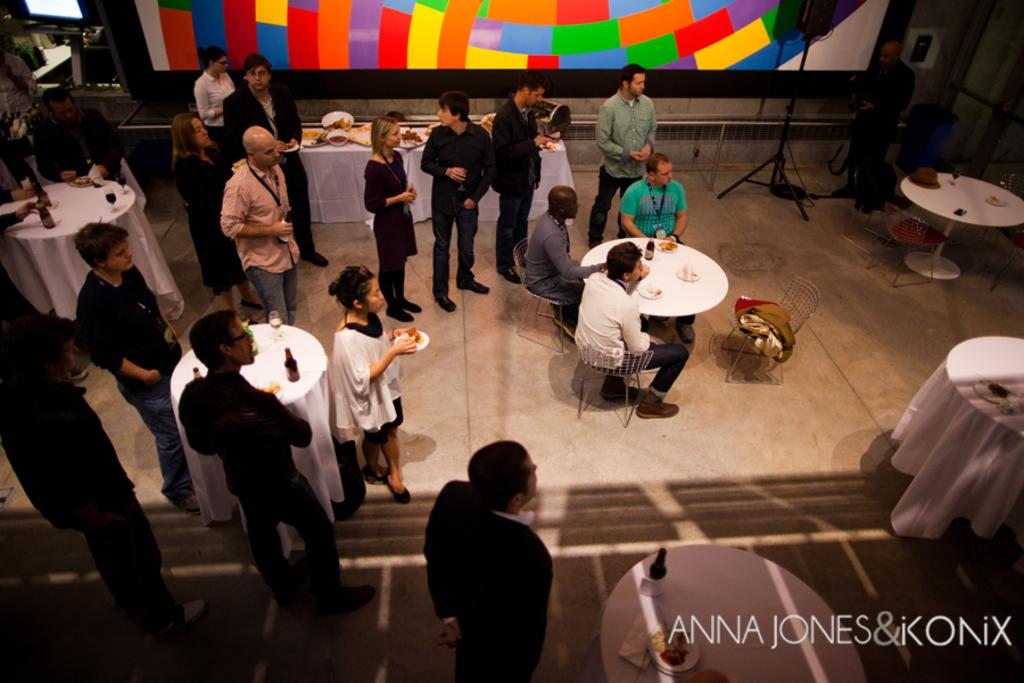What is present in the image that serves as a background? There is a wall in the image. What are the people in the image doing? The people in the image are standing and sitting. What type of furniture can be seen in the image? There are chairs and tables in the image. What items are placed on the tables? There are bottles and glasses on the tables. What type of soup is being served in the image? There is no soup present in the image. What is the purpose of the calculator on the table? There is no calculator present in the image. 